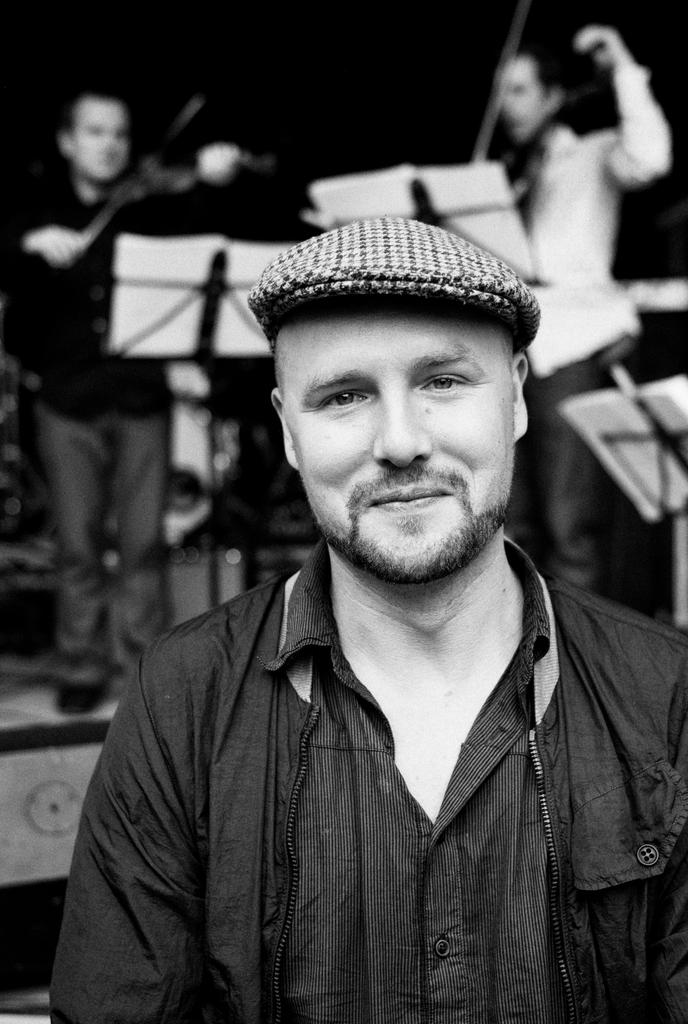What is the color scheme of the image? The image is black and white. Can you describe the person in the foreground of the image? There is a person wearing a cap in the image. How many people are visible in the background of the image? There are two persons in the background of the image. What objects are present in the image that might be related to reading or studying? There are book stands with books in the image. What type of plough is being used on the stage in the image? There is no plough or stage present in the image; it features a person wearing a cap and two persons in the background, along with book stands and books. 